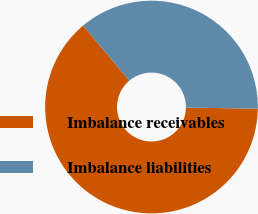<chart> <loc_0><loc_0><loc_500><loc_500><pie_chart><fcel>Imbalance receivables<fcel>Imbalance liabilities<nl><fcel>63.64%<fcel>36.36%<nl></chart> 